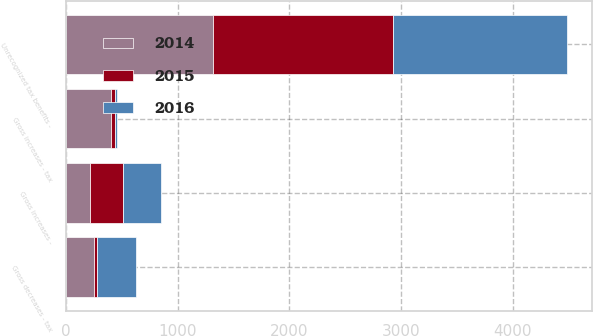Convert chart. <chart><loc_0><loc_0><loc_500><loc_500><stacked_bar_chart><ecel><fcel>Unrecognized tax benefits -<fcel>Gross increases - tax<fcel>Gross decreases - tax<fcel>Gross increases -<nl><fcel>2016<fcel>1557<fcel>17<fcel>348<fcel>344<nl><fcel>2015<fcel>1617<fcel>38<fcel>25<fcel>292<nl><fcel>2014<fcel>1312<fcel>403<fcel>251<fcel>217<nl></chart> 